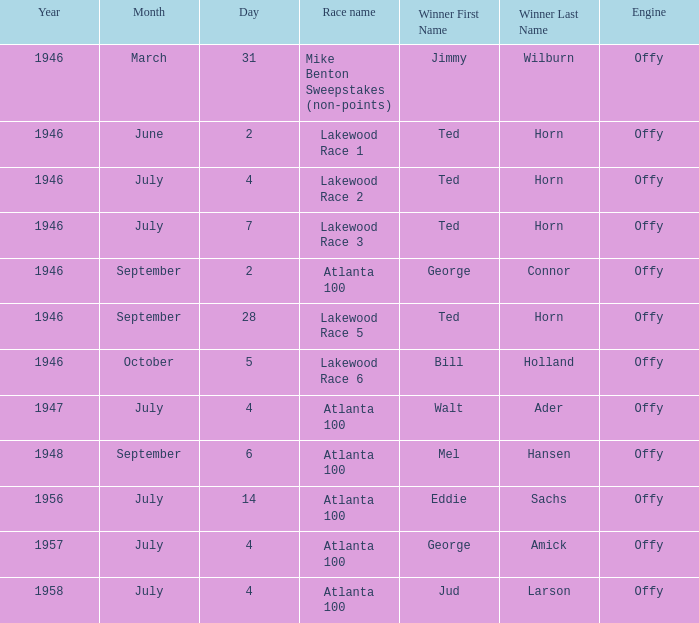Which race did Bill Holland win in 1946? Lakewood Race 6. 